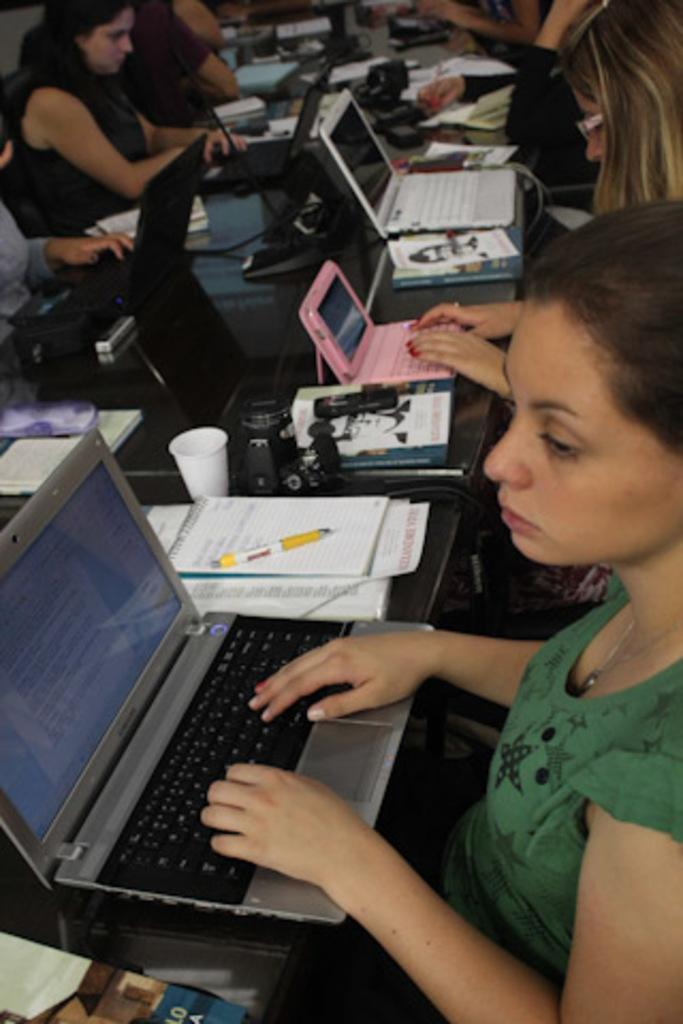What is the main object in the center of the image? There is a table in the center of the image. What electronic devices can be seen on the table? There are laptops on the table in the image. What else is present on the table besides laptops? There are books on the table in the image. Can you describe the people in the image? There are people sitting around the table in the image. How many cows are present in the image? There are no cows present in the image; it features a table with laptops and books, and people sitting around it. 